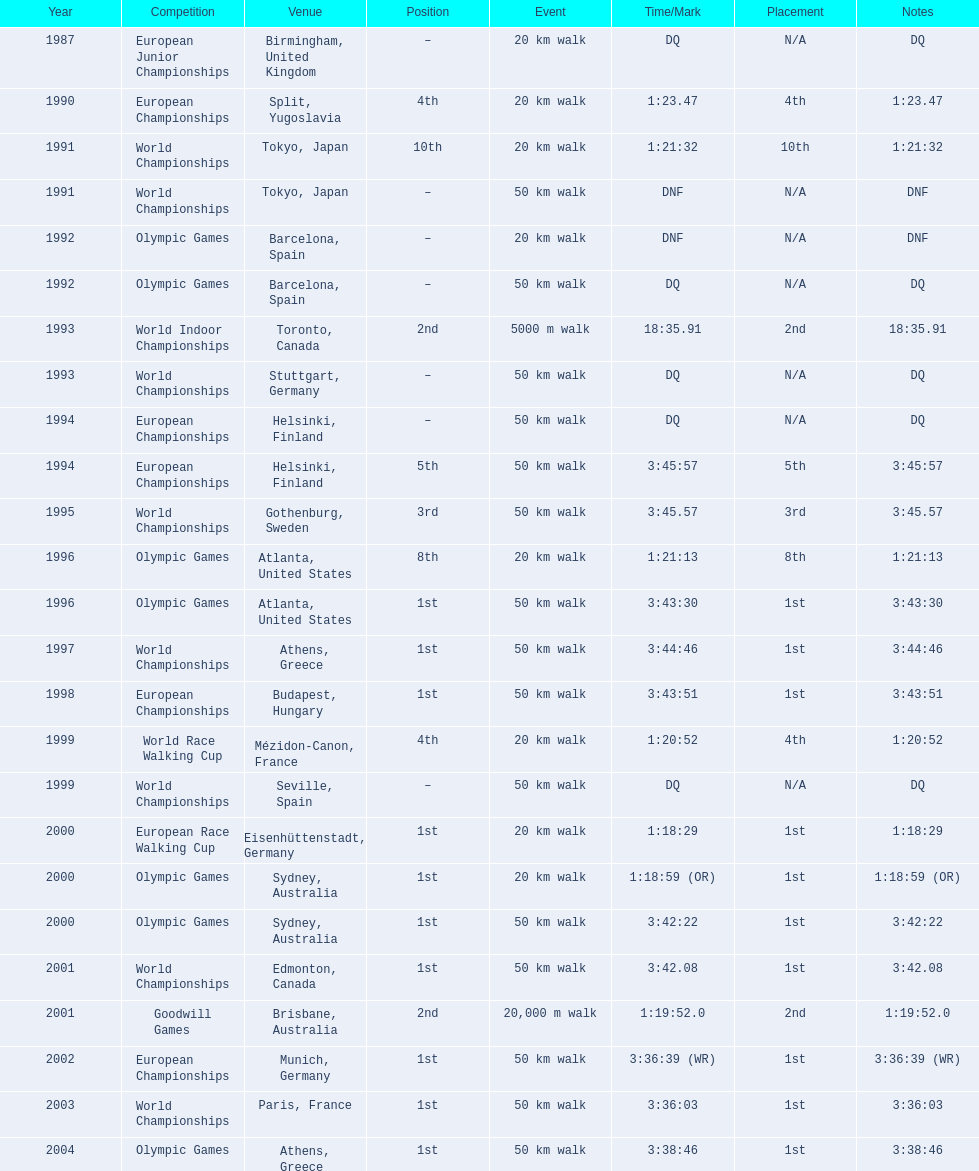What was the difference between korzeniowski's performance at the 1996 olympic games and the 2000 olympic games in the 20 km walk? 2:14. 